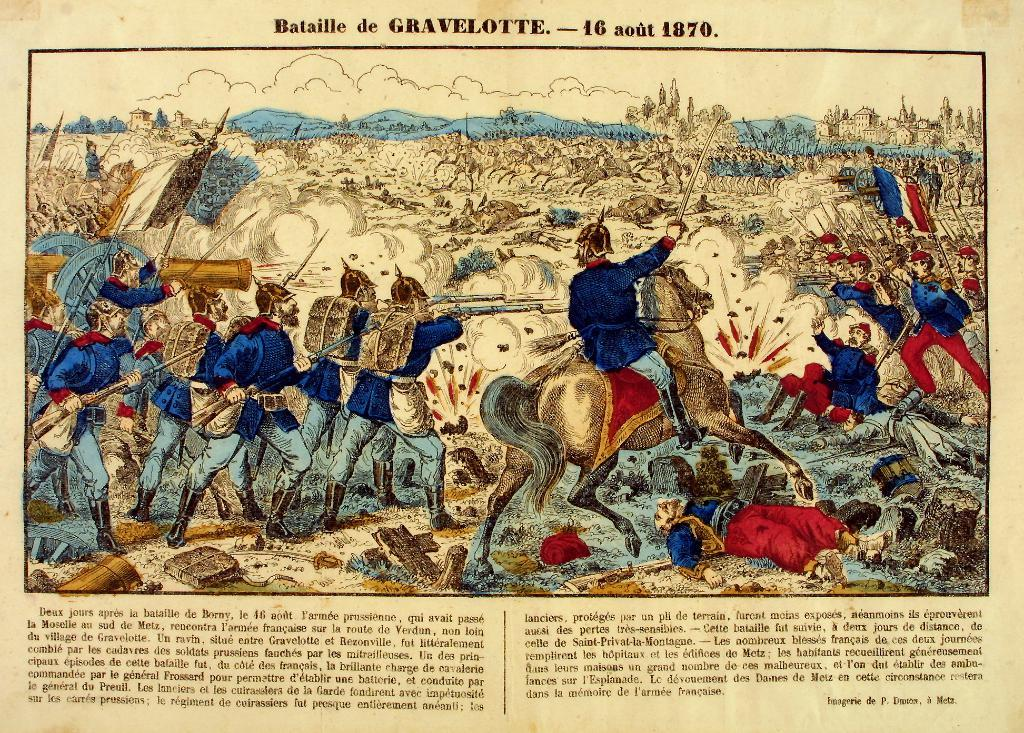What is present on the paper in the image? The paper contains text. How many people are in the image? There are at least one or more persons in the image. How many cards are being held by the team in the image? There is no mention of cards or a team in the image; it only contains a paper with text and at least one person. 